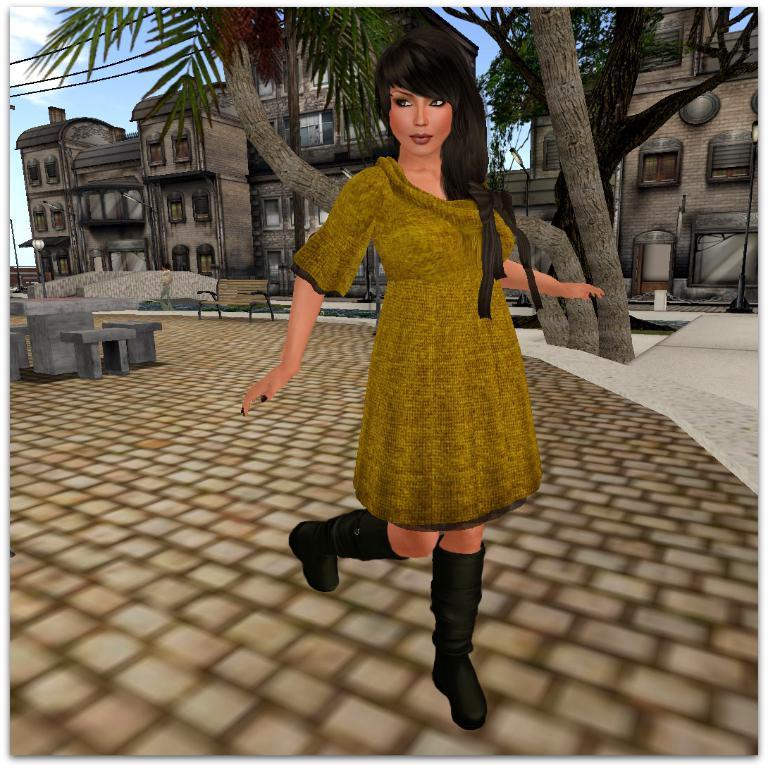Could you give a brief overview of what you see in this image? This is an animated image. In this image we can see a woman standing on the pathway. On the backside we can see some benches, poles, trees, a building, some wires, a person standing and the sky which looks cloudy. 